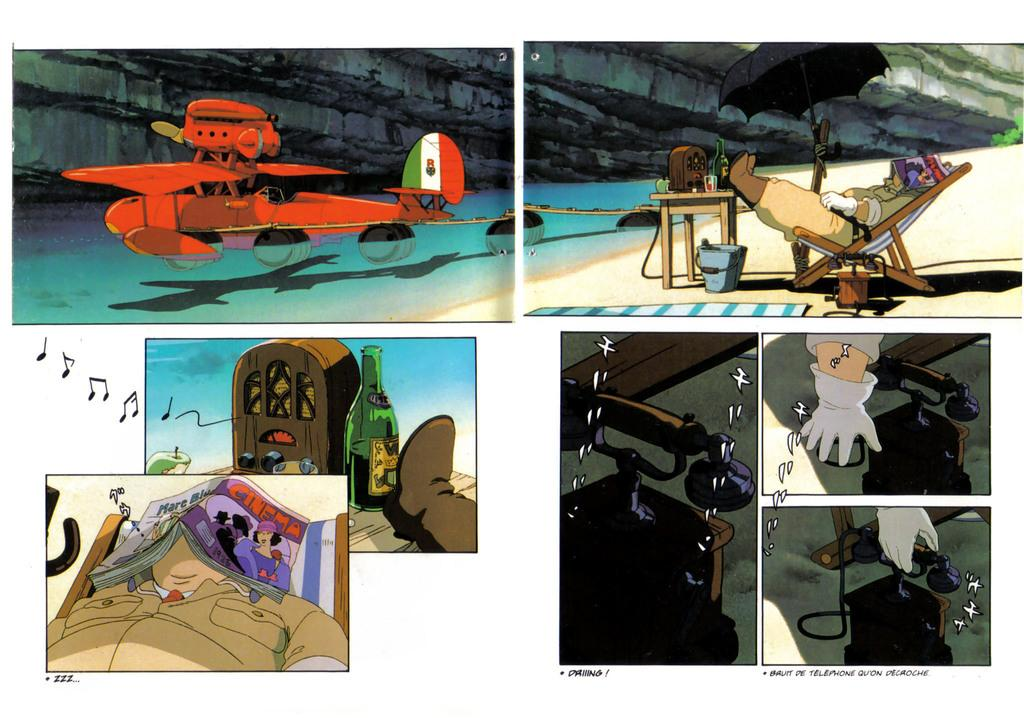<image>
Provide a brief description of the given image. a cartoon with several panes, one of which has a man sleeping nder a magazine with a cinema ad on the back 